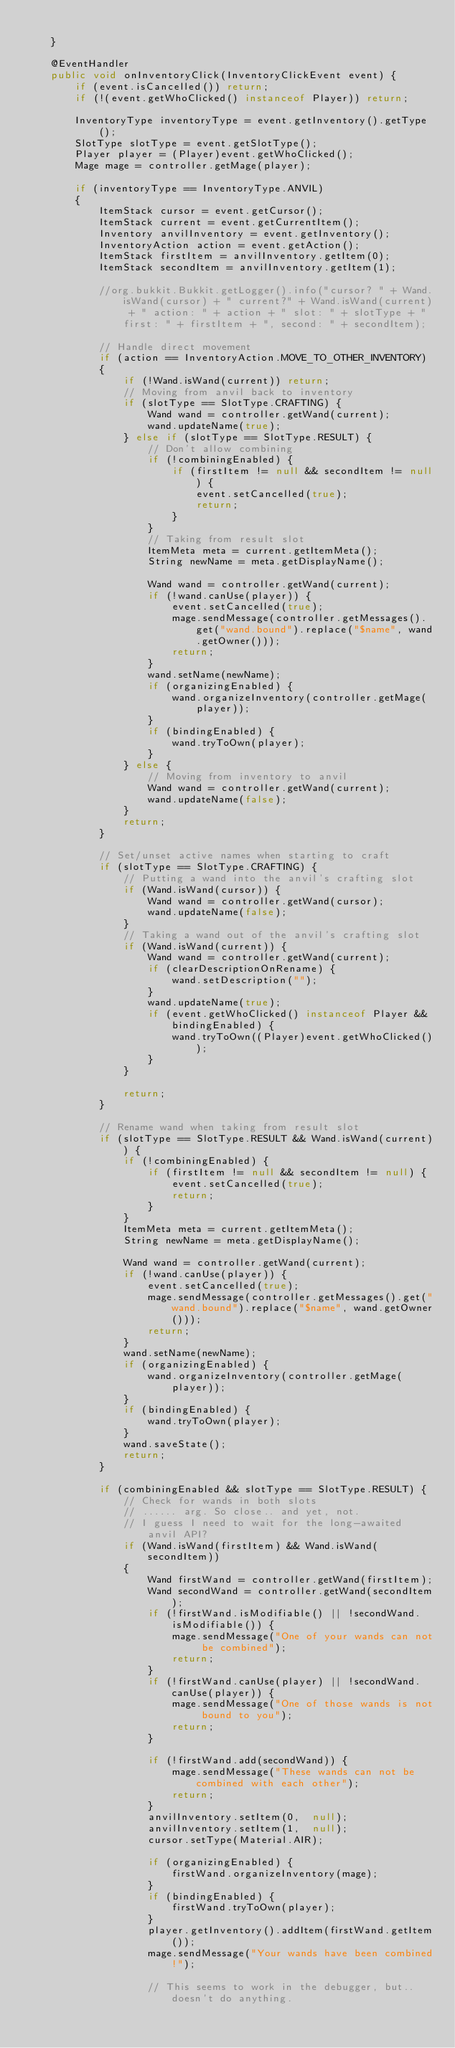<code> <loc_0><loc_0><loc_500><loc_500><_Java_>
    }

    @EventHandler
    public void onInventoryClick(InventoryClickEvent event) {
        if (event.isCancelled()) return;
        if (!(event.getWhoClicked() instanceof Player)) return;

        InventoryType inventoryType = event.getInventory().getType();
        SlotType slotType = event.getSlotType();
        Player player = (Player)event.getWhoClicked();
        Mage mage = controller.getMage(player);

        if (inventoryType == InventoryType.ANVIL)
        {
            ItemStack cursor = event.getCursor();
            ItemStack current = event.getCurrentItem();
            Inventory anvilInventory = event.getInventory();
            InventoryAction action = event.getAction();
            ItemStack firstItem = anvilInventory.getItem(0);
            ItemStack secondItem = anvilInventory.getItem(1);

            //org.bukkit.Bukkit.getLogger().info("cursor? " + Wand.isWand(cursor) + " current?" + Wand.isWand(current) + " action: " + action + " slot: " + slotType + " first: " + firstItem + ", second: " + secondItem);

            // Handle direct movement
            if (action == InventoryAction.MOVE_TO_OTHER_INVENTORY)
            {
                if (!Wand.isWand(current)) return;
                // Moving from anvil back to inventory
                if (slotType == SlotType.CRAFTING) {
                    Wand wand = controller.getWand(current);
                    wand.updateName(true);
                } else if (slotType == SlotType.RESULT) {
                    // Don't allow combining
                    if (!combiningEnabled) {
                        if (firstItem != null && secondItem != null) {
                            event.setCancelled(true);
                            return;
                        }
                    }
                    // Taking from result slot
                    ItemMeta meta = current.getItemMeta();
                    String newName = meta.getDisplayName();

                    Wand wand = controller.getWand(current);
                    if (!wand.canUse(player)) {
                        event.setCancelled(true);
                        mage.sendMessage(controller.getMessages().get("wand.bound").replace("$name", wand.getOwner()));
                        return;
                    }
                    wand.setName(newName);
                    if (organizingEnabled) {
                        wand.organizeInventory(controller.getMage(player));
                    }
                    if (bindingEnabled) {
                        wand.tryToOwn(player);
                    }
                } else {
                    // Moving from inventory to anvil
                    Wand wand = controller.getWand(current);
                    wand.updateName(false);
                }
                return;
            }

            // Set/unset active names when starting to craft
            if (slotType == SlotType.CRAFTING) {
                // Putting a wand into the anvil's crafting slot
                if (Wand.isWand(cursor)) {
                    Wand wand = controller.getWand(cursor);
                    wand.updateName(false);
                }
                // Taking a wand out of the anvil's crafting slot
                if (Wand.isWand(current)) {
                    Wand wand = controller.getWand(current);
                    if (clearDescriptionOnRename) {
                        wand.setDescription("");
                    }
                    wand.updateName(true);
                    if (event.getWhoClicked() instanceof Player && bindingEnabled) {
                        wand.tryToOwn((Player)event.getWhoClicked());
                    }
                }

                return;
            }

            // Rename wand when taking from result slot
            if (slotType == SlotType.RESULT && Wand.isWand(current)) {
                if (!combiningEnabled) {
                    if (firstItem != null && secondItem != null) {
                        event.setCancelled(true);
                        return;
                    }
                }
                ItemMeta meta = current.getItemMeta();
                String newName = meta.getDisplayName();

                Wand wand = controller.getWand(current);
                if (!wand.canUse(player)) {
                    event.setCancelled(true);
                    mage.sendMessage(controller.getMessages().get("wand.bound").replace("$name", wand.getOwner()));
                    return;
                }
                wand.setName(newName);
                if (organizingEnabled) {
                    wand.organizeInventory(controller.getMage(player));
                }
                if (bindingEnabled) {
                    wand.tryToOwn(player);
                }
                wand.saveState();
                return;
            }

            if (combiningEnabled && slotType == SlotType.RESULT) {
                // Check for wands in both slots
                // ...... arg. So close.. and yet, not.
                // I guess I need to wait for the long-awaited anvil API?
                if (Wand.isWand(firstItem) && Wand.isWand(secondItem))
                {
                    Wand firstWand = controller.getWand(firstItem);
                    Wand secondWand = controller.getWand(secondItem);
                    if (!firstWand.isModifiable() || !secondWand.isModifiable()) {
                        mage.sendMessage("One of your wands can not be combined");
                        return;
                    }
                    if (!firstWand.canUse(player) || !secondWand.canUse(player)) {
                        mage.sendMessage("One of those wands is not bound to you");
                        return;
                    }

                    if (!firstWand.add(secondWand)) {
                        mage.sendMessage("These wands can not be combined with each other");
                        return;
                    }
                    anvilInventory.setItem(0,  null);
                    anvilInventory.setItem(1,  null);
                    cursor.setType(Material.AIR);

                    if (organizingEnabled) {
                        firstWand.organizeInventory(mage);
                    }
                    if (bindingEnabled) {
                        firstWand.tryToOwn(player);
                    }
                    player.getInventory().addItem(firstWand.getItem());
                    mage.sendMessage("Your wands have been combined!");

                    // This seems to work in the debugger, but.. doesn't do anything.</code> 